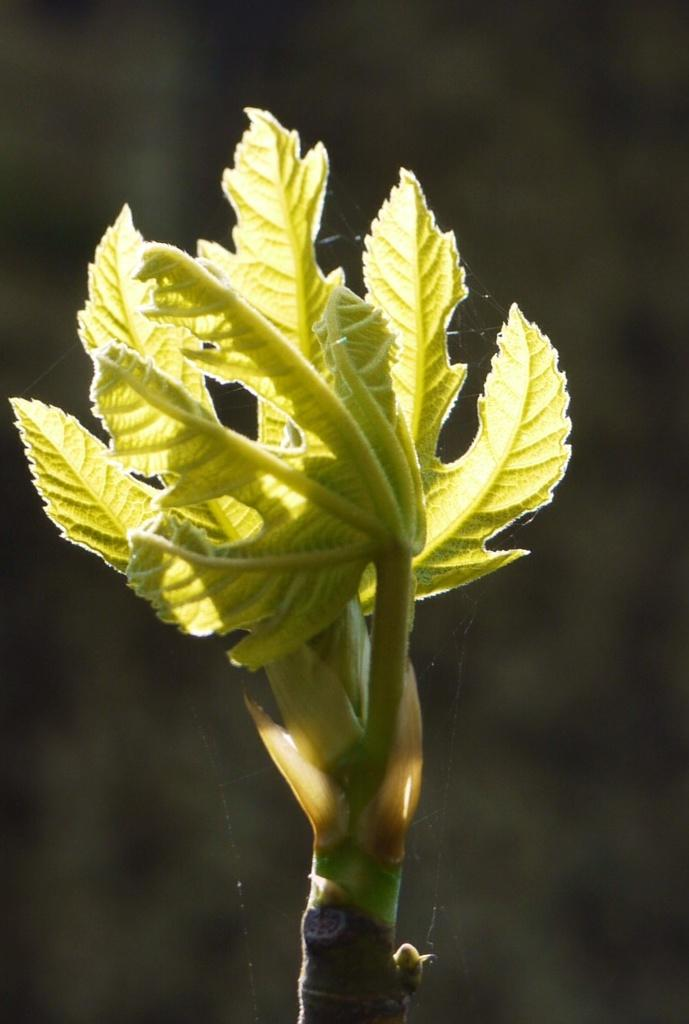What is present in the image? There is a plant in the image. What can be said about the color of the plant? The plant is green in color. Where is the basketball located in the image? There is no basketball present in the image. What type of carriage is being used to transport the plant in the image? There is no carriage present in the image; it is a plant without any transportation device. 